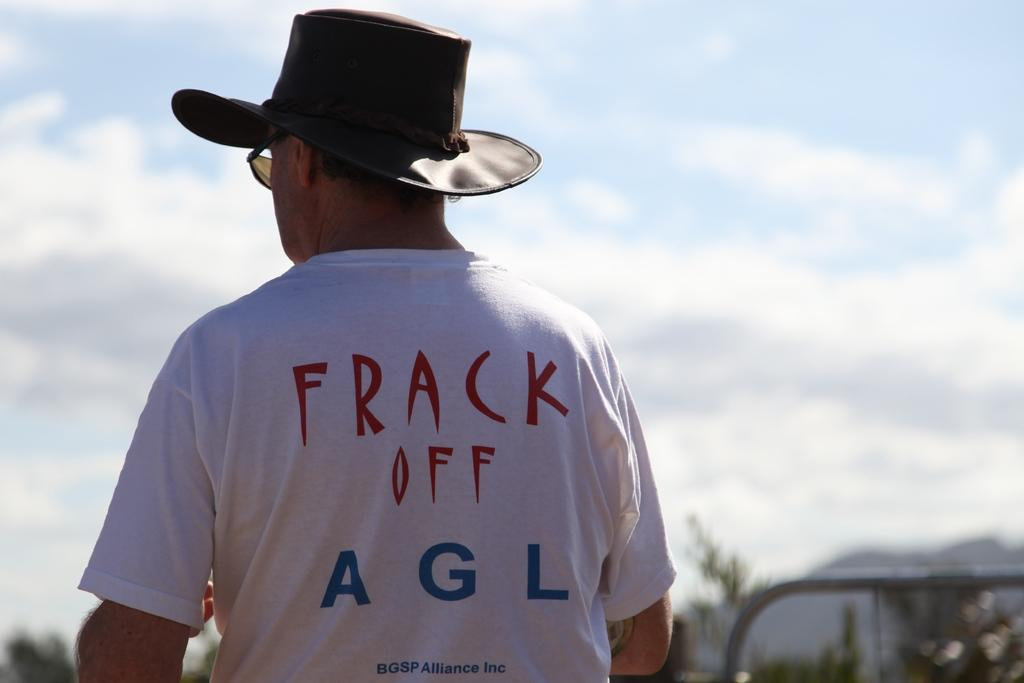<image>
Summarize the visual content of the image. A man wearing sunglasses and a hat with a Frack Off AGL shirt. 